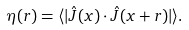<formula> <loc_0><loc_0><loc_500><loc_500>\eta ( r ) = \langle | \hat { J } ( x ) \cdot \hat { J } ( x + r ) | \rangle .</formula> 